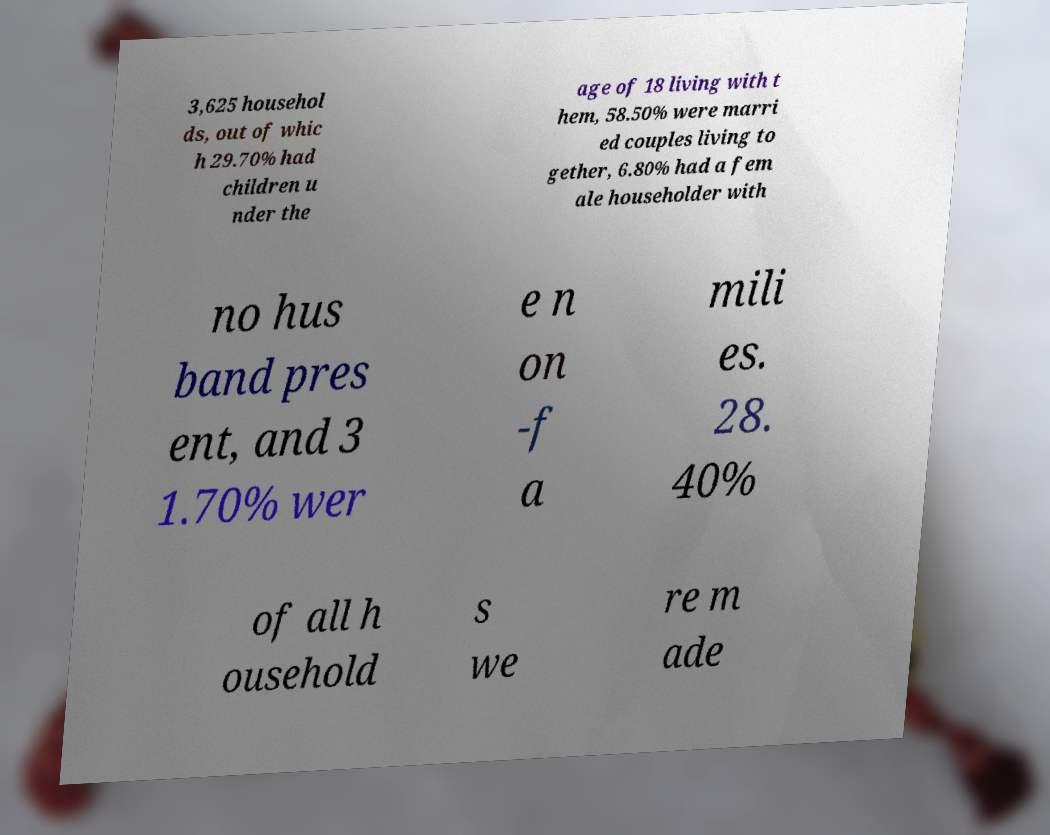Could you assist in decoding the text presented in this image and type it out clearly? 3,625 househol ds, out of whic h 29.70% had children u nder the age of 18 living with t hem, 58.50% were marri ed couples living to gether, 6.80% had a fem ale householder with no hus band pres ent, and 3 1.70% wer e n on -f a mili es. 28. 40% of all h ousehold s we re m ade 